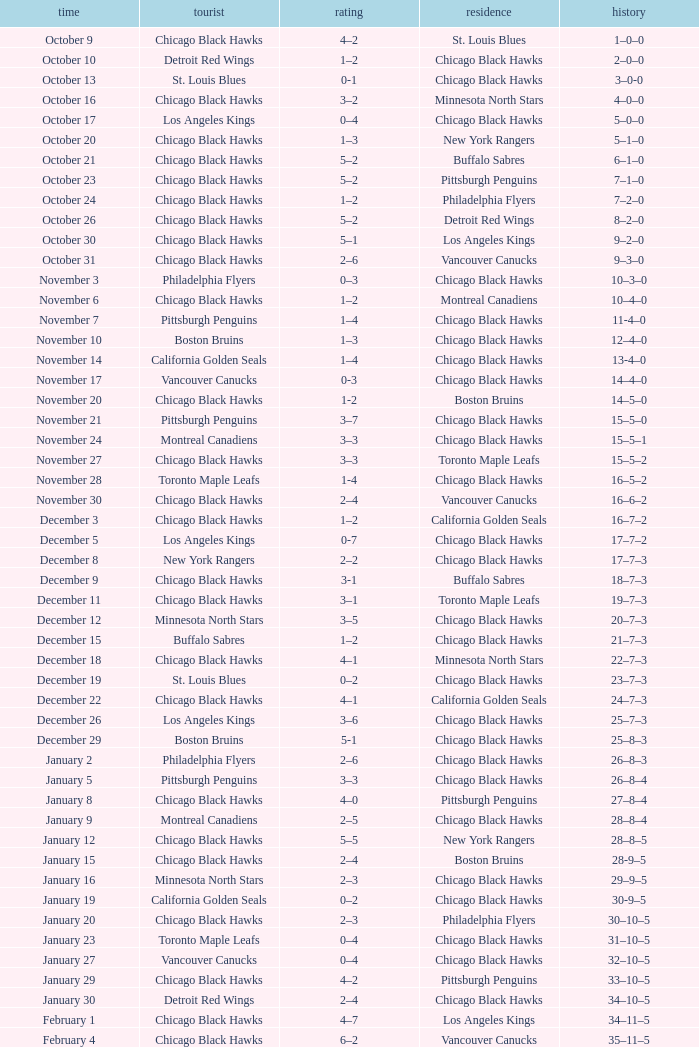What is the Record from February 10? 36–13–5. 